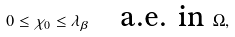Convert formula to latex. <formula><loc_0><loc_0><loc_500><loc_500>0 \leq \chi _ { 0 } \leq \lambda _ { \beta } \quad \text {a.e. in } \Omega ,</formula> 